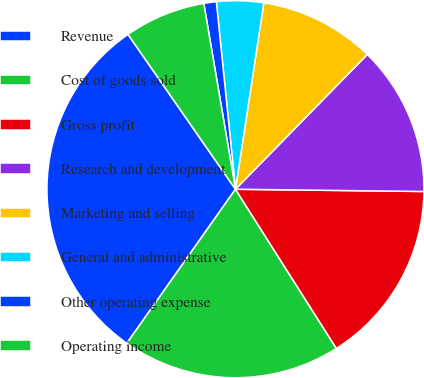Convert chart to OTSL. <chart><loc_0><loc_0><loc_500><loc_500><pie_chart><fcel>Revenue<fcel>Cost of goods sold<fcel>Gross profit<fcel>Research and development<fcel>Marketing and selling<fcel>General and administrative<fcel>Other operating expense<fcel>Operating income<nl><fcel>30.57%<fcel>18.77%<fcel>15.82%<fcel>12.87%<fcel>9.92%<fcel>4.02%<fcel>1.07%<fcel>6.97%<nl></chart> 